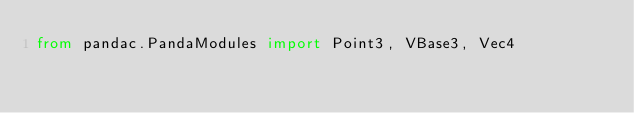Convert code to text. <code><loc_0><loc_0><loc_500><loc_500><_Python_>from pandac.PandaModules import Point3, VBase3, Vec4</code> 